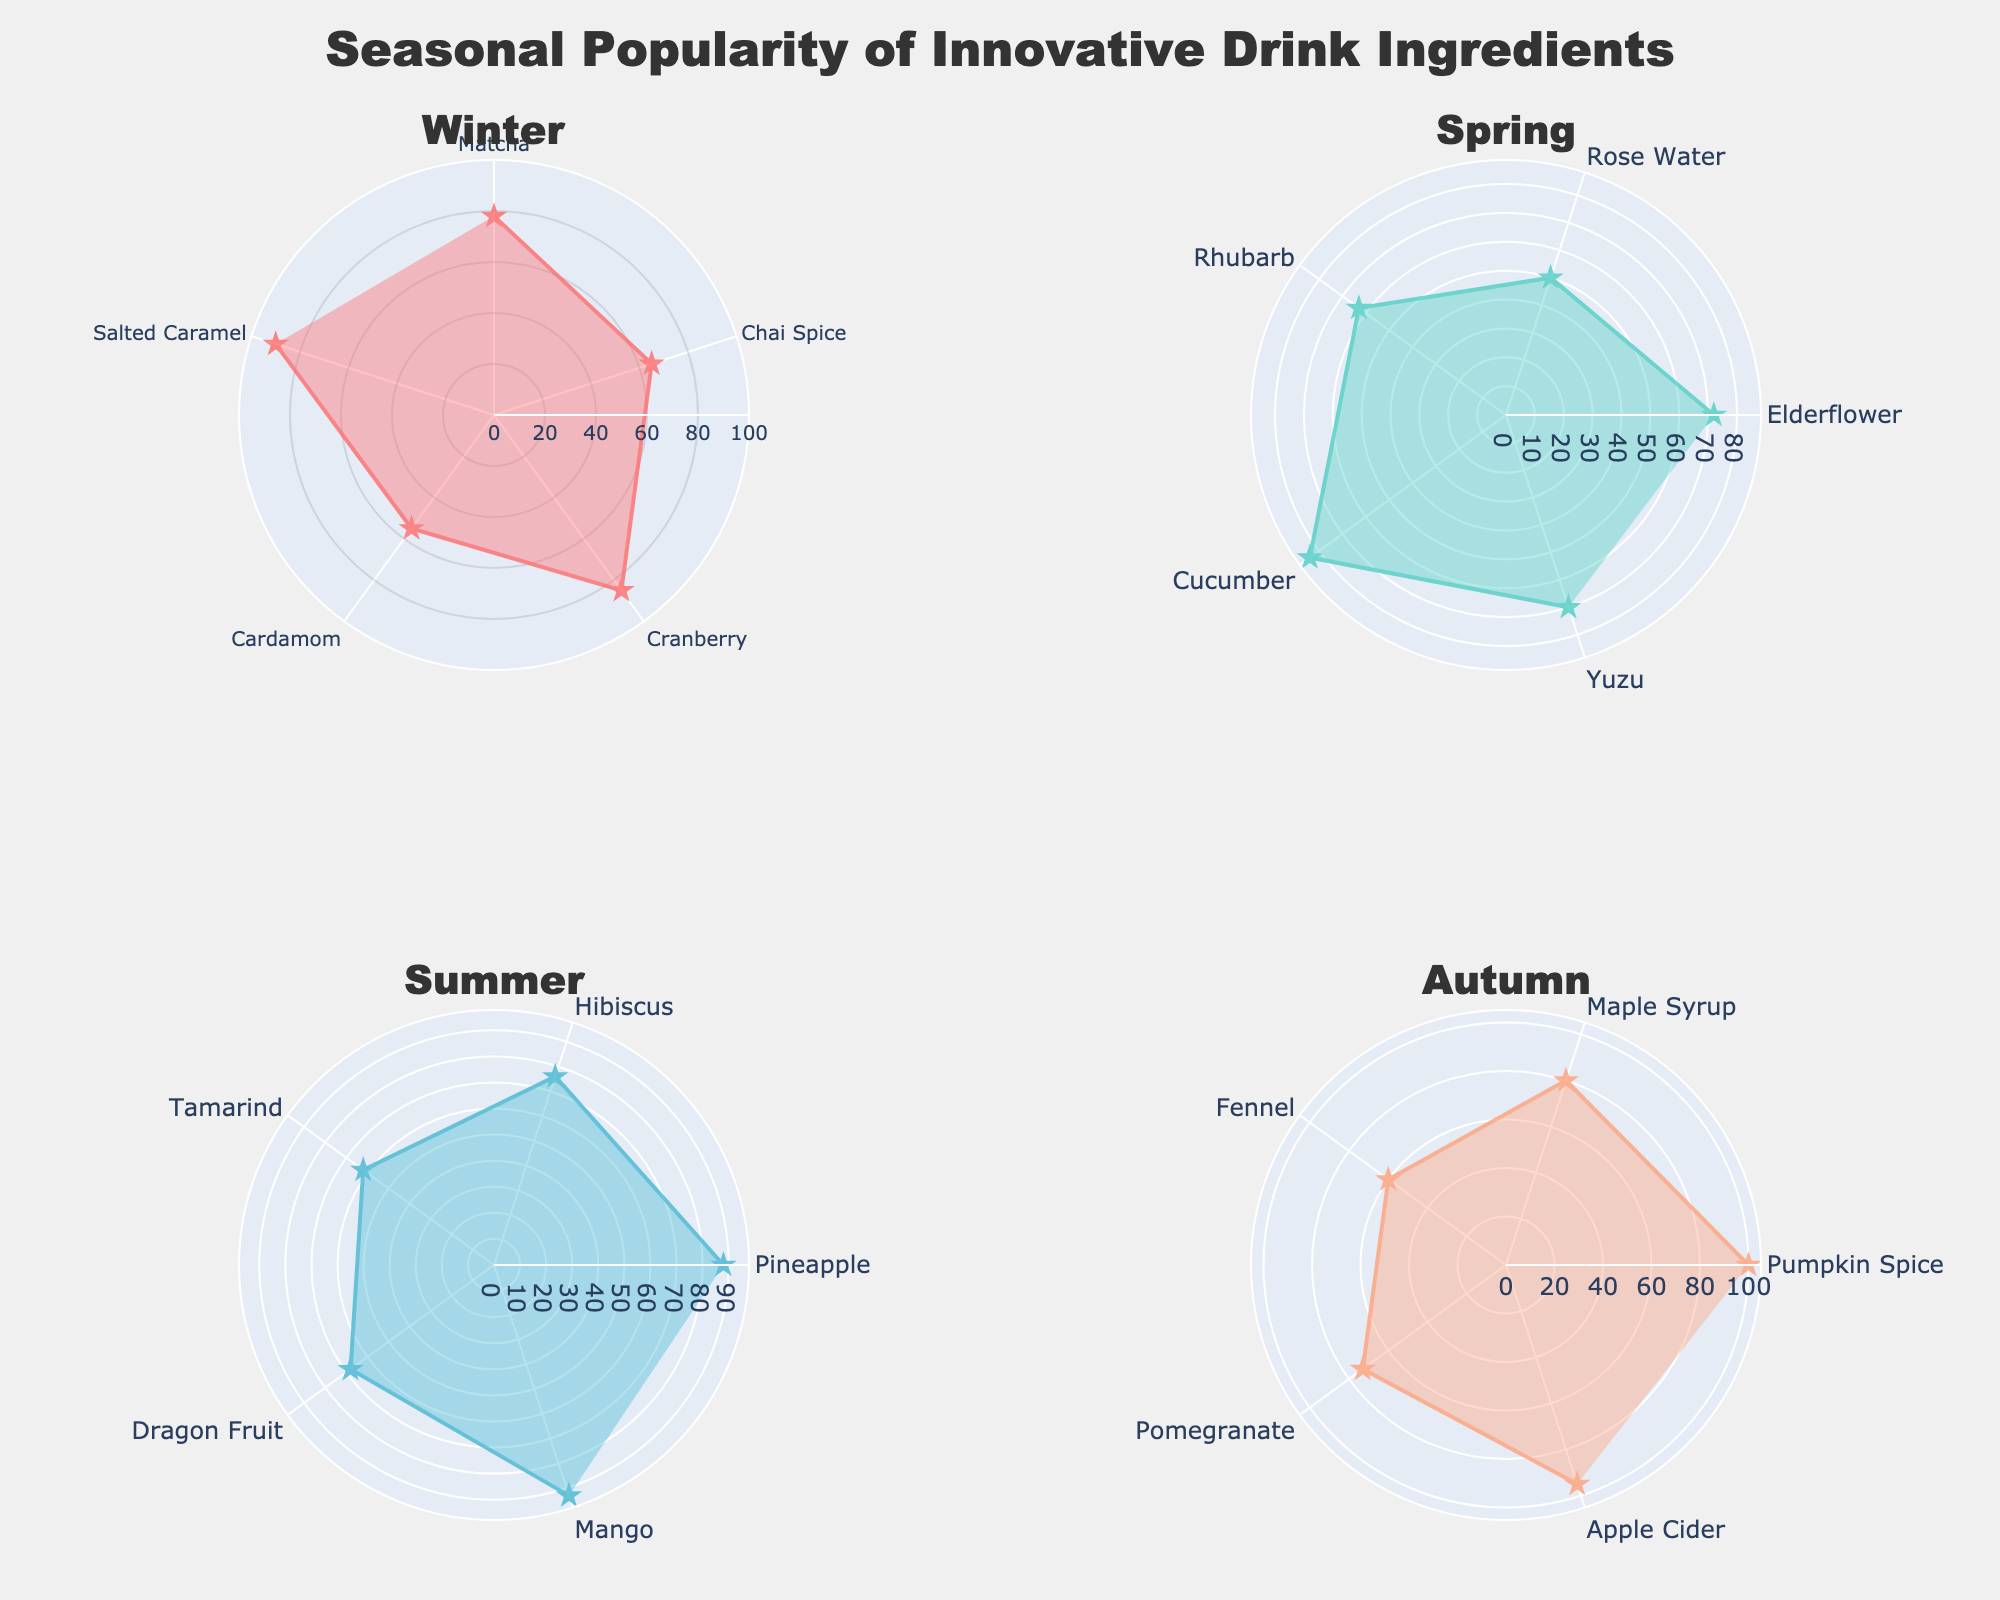What is the title of the figure? The title of the figure is located at the top center of the chart. It reads "Seasonal Popularity of Innovative Drink Ingredients".
Answer: Seasonal Popularity of Innovative Drink Ingredients Which season's plot uses the most intense red color? The figure uses specific colors for each season. Winter's plot uses the most intense red color based on the provided color schemes.
Answer: Winter What ingredient in Autumn has the highest popularity? The plot for Autumn shows the highest point on its radial axis corresponding to Pumpkin Spice, which reaches a value at the top of the scale.
Answer: Pumpkin Spice Which season exhibits the least variance in ingredient popularity? By observing the spread of popularity values around the circle for each season, Spring shows a relatively consistent concentration of values, suggesting the least variance.
Answer: Spring What is the average popularity of winter ingredients? Add the popularity values of winter ingredients (Matcha: 78, Chai Spice: 65, Cranberry: 85, Cardamom: 55, Salted Caramel: 90), then divide by the number of ingredients. (78 + 65 + 85 + 55 + 90) / 5 = 373 / 5 = 74.6
Answer: 74.6 How does Summer's most popular ingredient compare to its least popular one? In the Summer plot, the highest popularity value is Mango at 93, and the lowest is Tamarind at 62. The difference can be calculated as 93 - 62 = 31.
Answer: 31 Which winter ingredient is least popular, and what is its value? On the Winter plot, the ingredient with the lowest value on the radial axis is Cardamom, with a popularity of 55.
Answer: Cardamom, 55 Compare the most popular ingredients in Winter and Autumn. Which is more popular and by how much? Winter's most popular ingredient is Salted Caramel (90), and Autumn's is Pumpkin Spice (100). The difference is 100 - 90 = 10. Pumpkin Spice is more popular by 10 points.
Answer: Pumpkin Spice by 10 points What's the range of popularity values for ingredients in Spring? The highest value in Spring is for Cucumber (84), and the lowest is for Rose Water (50). The range is calculated as 84 - 50 = 34.
Answer: 34 Which season has the highest overall peak value for any ingredient, and what is that value? By comparing the maximum values across all seasons, Autumn has the highest peak with Pumpkin Spice at 100.
Answer: Autumn, 100 